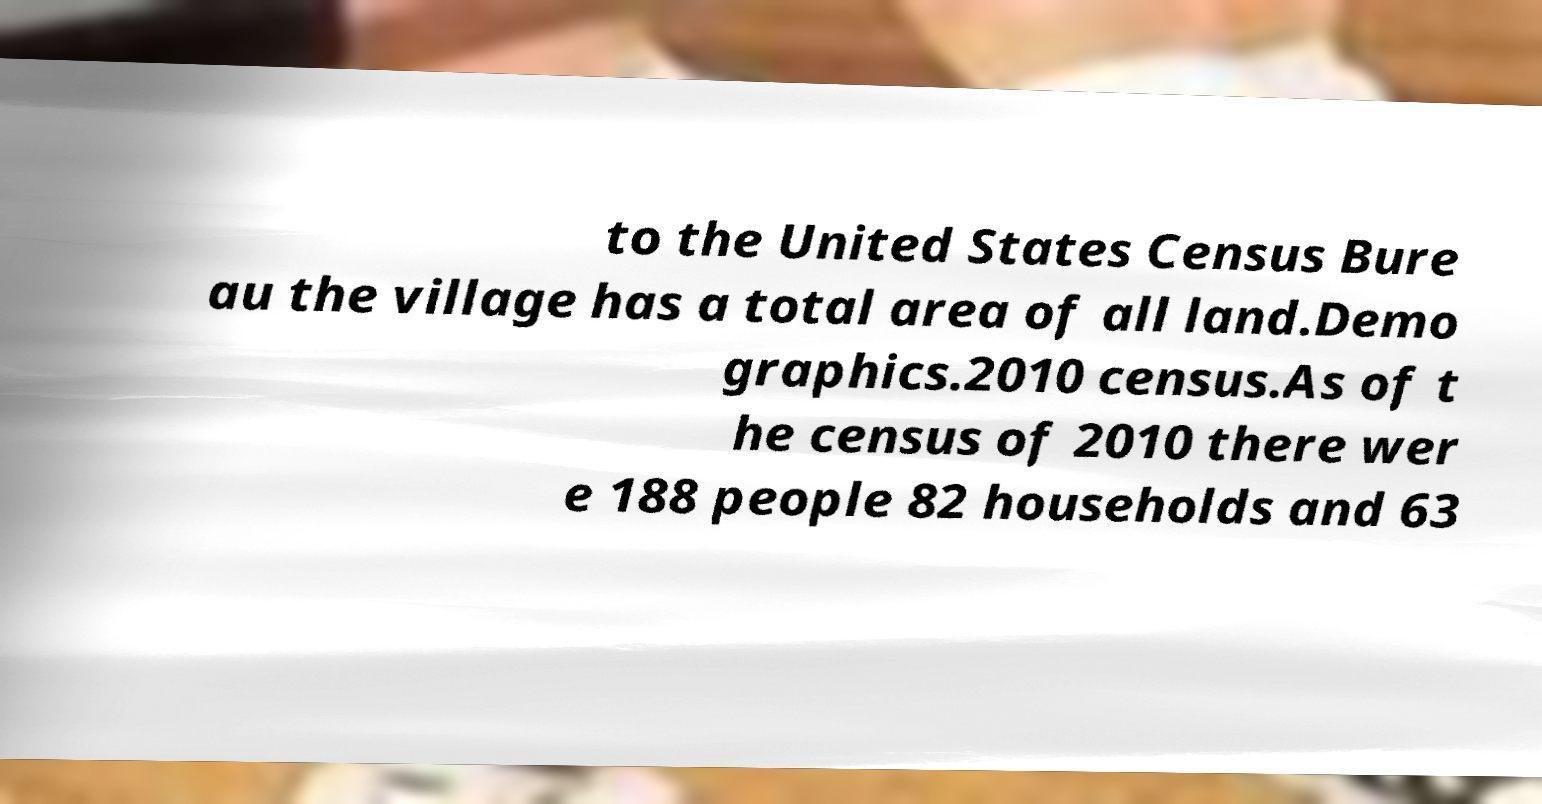Could you assist in decoding the text presented in this image and type it out clearly? to the United States Census Bure au the village has a total area of all land.Demo graphics.2010 census.As of t he census of 2010 there wer e 188 people 82 households and 63 